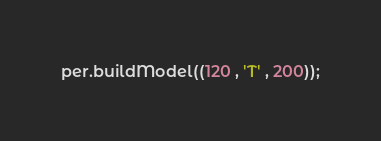<code> <loc_0><loc_0><loc_500><loc_500><_Python_>per.buildModel((120 , 'T' , 200));

</code> 